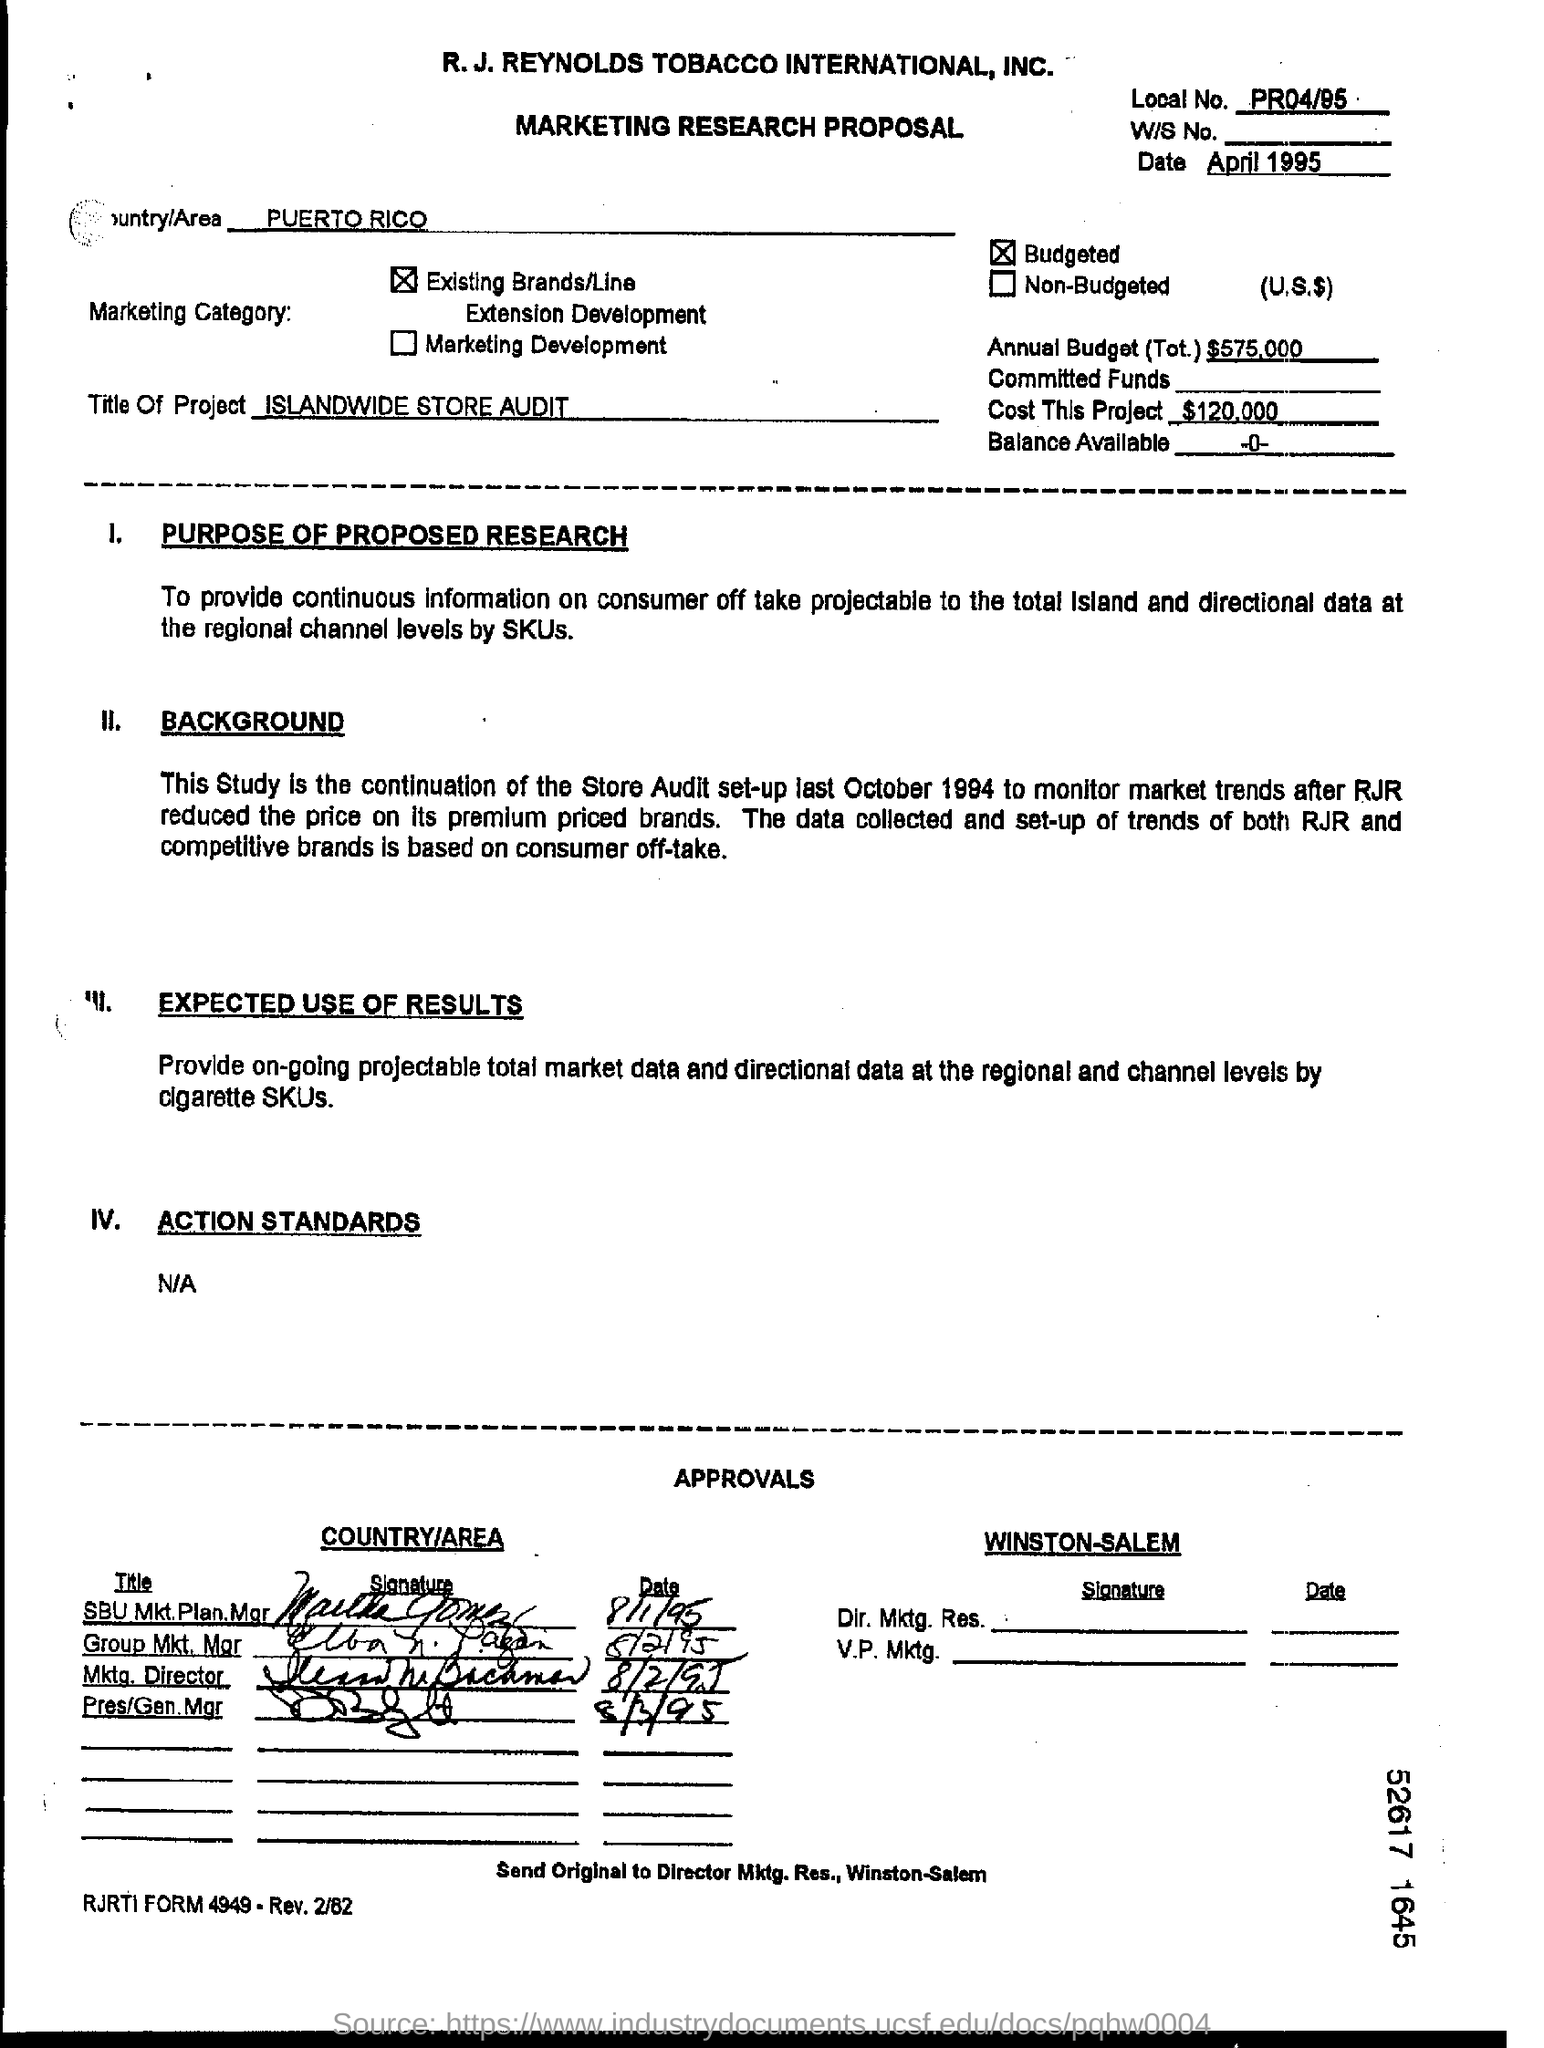How much is the total annual budget?
Make the answer very short. $575,000. What is the cost of the project?
Provide a succinct answer. $120,000. What is the name of the country or area?
Your answer should be compact. PUERTO RICO. When is the proposal dated?
Offer a very short reply. April 1995. 